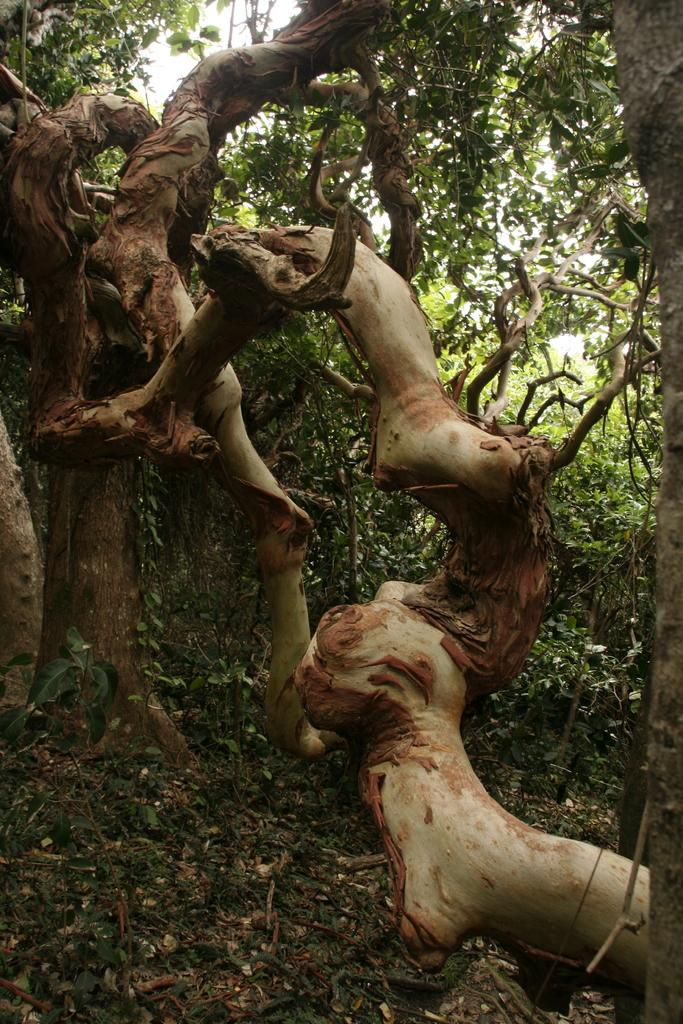What is the main subject in the middle of the image? There is a big tree trunk in the middle of the image. What can be seen on the ground at the bottom of the image? Dry leaves are present on the ground at the bottom of the image. What is visible in the background of the image? There are trees visible in the background of the image. Can you see the tail of the animal hiding behind the tree trunk in the image? There is no animal or tail visible in the image; it only features a big tree trunk and dry leaves on the ground. 